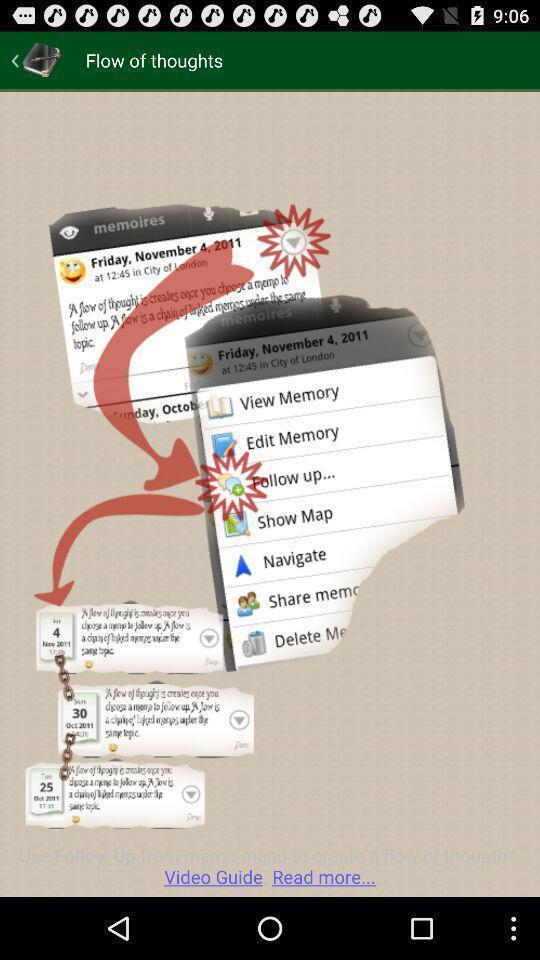Summarize the main components in this picture. Screen shows images to keep records. 